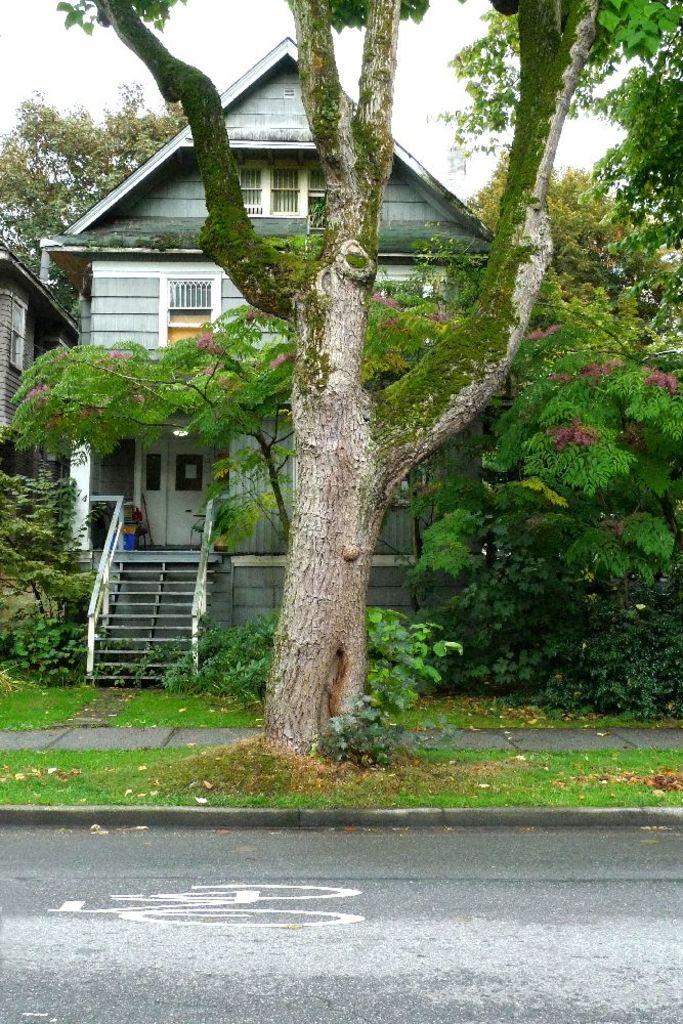What type of structure is visible in the image? There is a house in the image. What feature allows access to different levels of the house? There are stairs in the image. What type of vegetation is present in the image? There is grass, a plant, and trees in the image. What type of pathway is visible in the image? There is a road in the image. What type of screw can be seen holding the plant to the wall in the image? There is no screw visible in the image, and the plant is not attached to the wall. How many fingers can be seen pointing at the house in the image? There are no fingers visible in the image. 